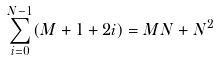<formula> <loc_0><loc_0><loc_500><loc_500>\sum _ { i = 0 } ^ { N - 1 } ( M + 1 + 2 i ) = M N + N ^ { 2 }</formula> 